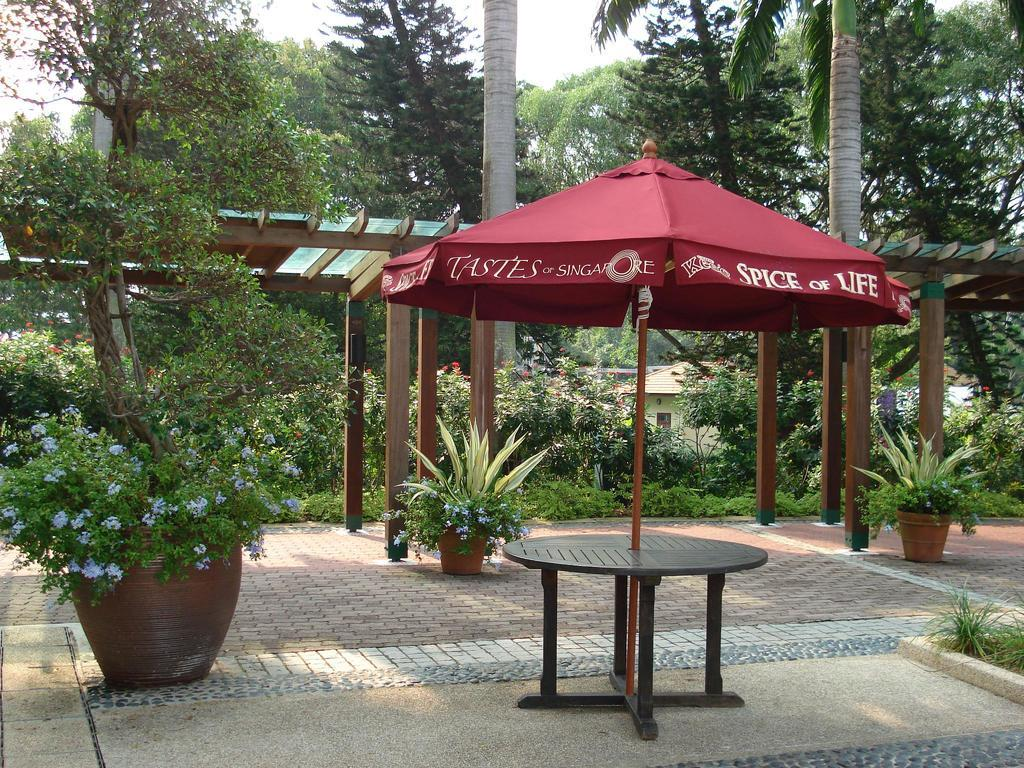What type of furniture is present in the image? There is a table in the image. What type of vegetation is present in the image? There are plants in pots and trees in the image. Can you see any goldfish swimming in the image? There are no goldfish present in the image. What type of chess pieces can be seen on the table in the image? There is no mention of chess pieces or a chess set in the image. 